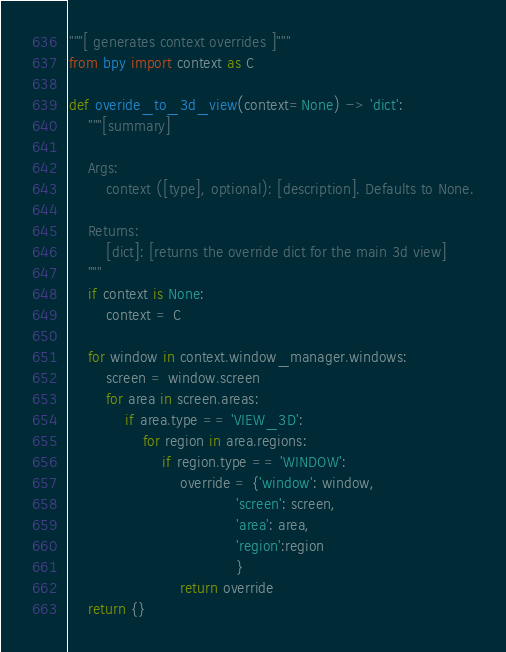Convert code to text. <code><loc_0><loc_0><loc_500><loc_500><_Python_>"""[ generates context overrides ]"""
from bpy import context as C

def overide_to_3d_view(context=None) -> 'dict':
    """[summary]

    Args:
        context ([type], optional): [description]. Defaults to None.

    Returns:
        [dict]: [returns the override dict for the main 3d view]
    """
    if context is None:
        context = C
    
    for window in context.window_manager.windows:
        screen = window.screen
        for area in screen.areas:
            if area.type == 'VIEW_3D':
                for region in area.regions:
                    if region.type == 'WINDOW':
                        override = {'window': window,
                                    'screen': screen,
                                    'area': area,
                                    'region':region
                                    }
                        return override
    return {}
</code> 